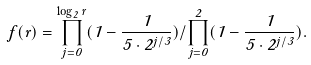<formula> <loc_0><loc_0><loc_500><loc_500>f ( r ) = \prod _ { j = 0 } ^ { \log _ { 2 } r } ( 1 - \frac { 1 } { 5 \cdot 2 ^ { j / 3 } } ) / \prod _ { j = 0 } ^ { 2 } ( 1 - \frac { 1 } { 5 \cdot 2 ^ { j / 3 } } ) .</formula> 